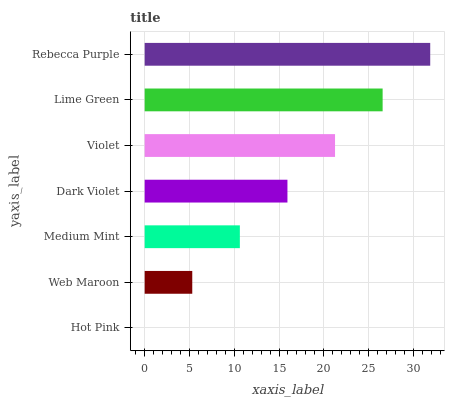Is Hot Pink the minimum?
Answer yes or no. Yes. Is Rebecca Purple the maximum?
Answer yes or no. Yes. Is Web Maroon the minimum?
Answer yes or no. No. Is Web Maroon the maximum?
Answer yes or no. No. Is Web Maroon greater than Hot Pink?
Answer yes or no. Yes. Is Hot Pink less than Web Maroon?
Answer yes or no. Yes. Is Hot Pink greater than Web Maroon?
Answer yes or no. No. Is Web Maroon less than Hot Pink?
Answer yes or no. No. Is Dark Violet the high median?
Answer yes or no. Yes. Is Dark Violet the low median?
Answer yes or no. Yes. Is Medium Mint the high median?
Answer yes or no. No. Is Lime Green the low median?
Answer yes or no. No. 